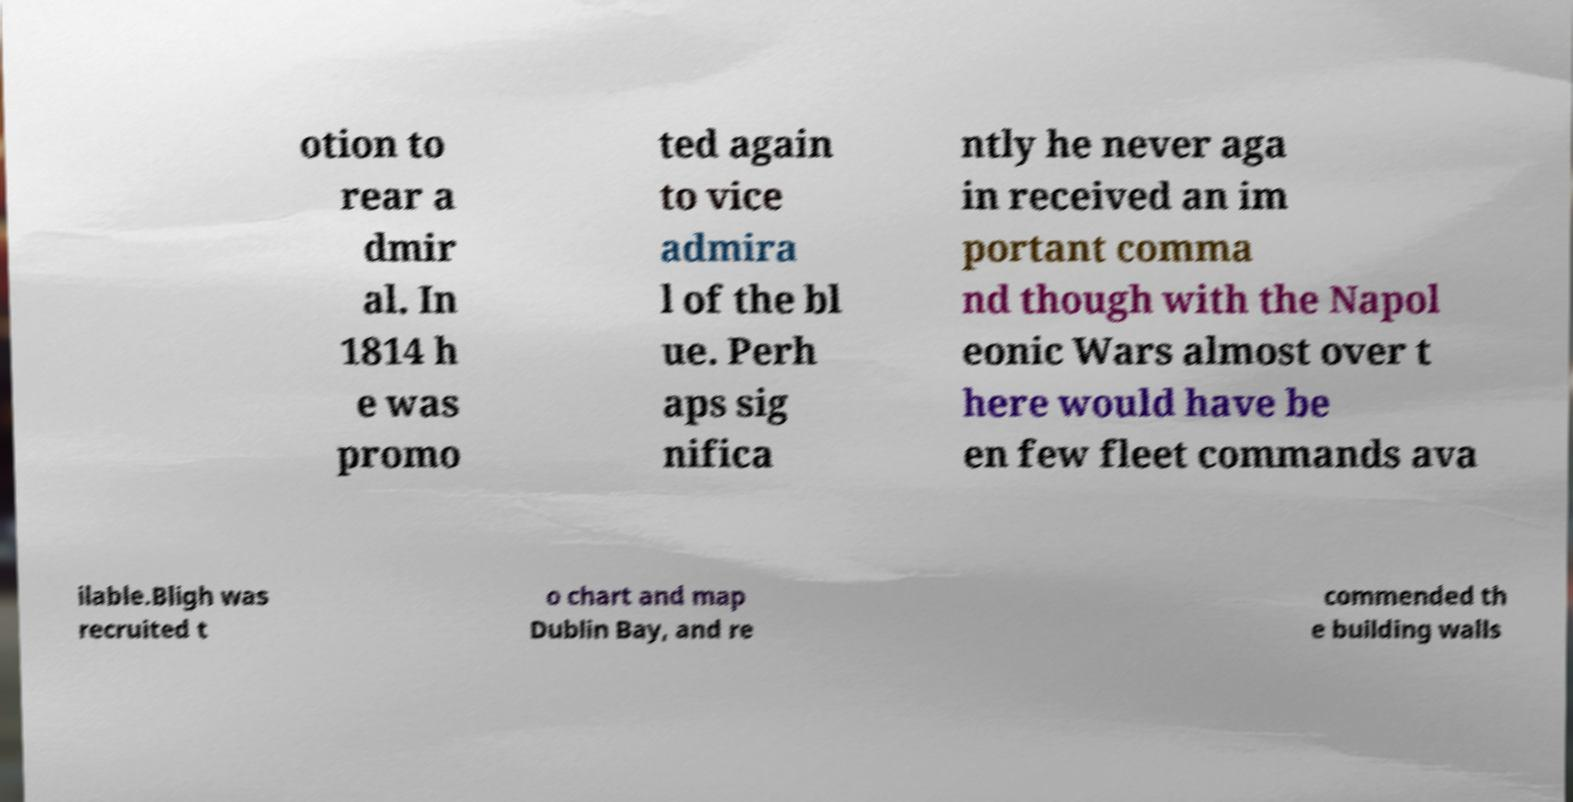Can you read and provide the text displayed in the image?This photo seems to have some interesting text. Can you extract and type it out for me? otion to rear a dmir al. In 1814 h e was promo ted again to vice admira l of the bl ue. Perh aps sig nifica ntly he never aga in received an im portant comma nd though with the Napol eonic Wars almost over t here would have be en few fleet commands ava ilable.Bligh was recruited t o chart and map Dublin Bay, and re commended th e building walls 